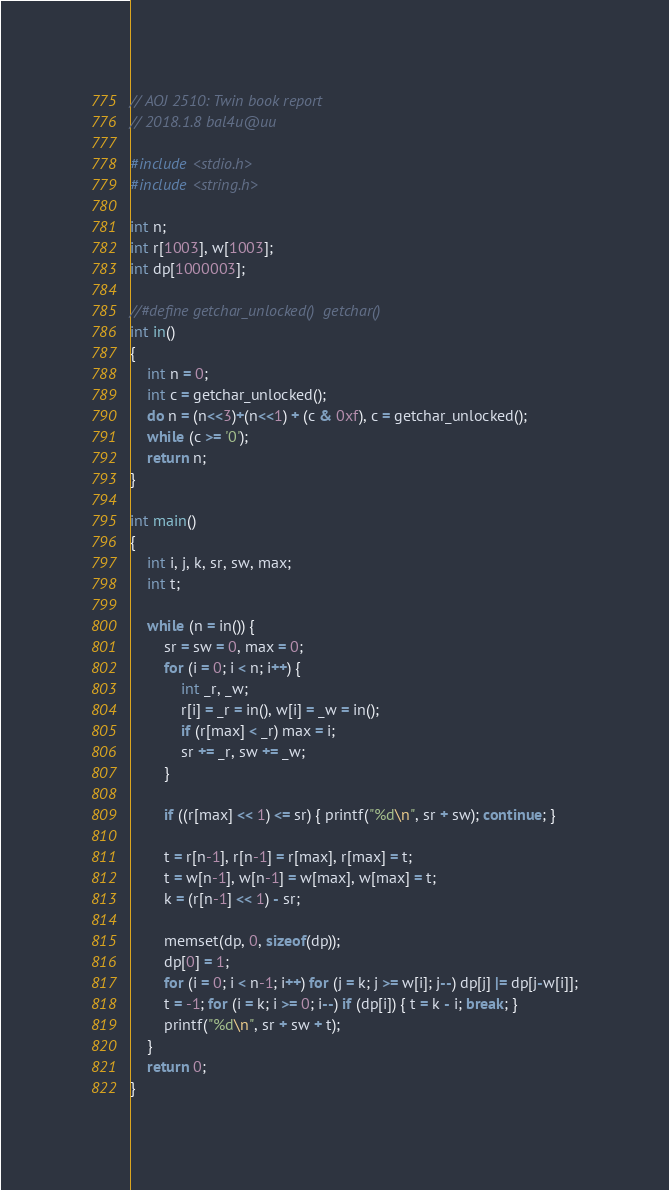<code> <loc_0><loc_0><loc_500><loc_500><_C_>// AOJ 2510: Twin book report
// 2018.1.8 bal4u@uu

#include <stdio.h>
#include <string.h>

int n;
int r[1003], w[1003];
int dp[1000003];

//#define getchar_unlocked()  getchar()
int in()
{
	int n = 0;
	int c = getchar_unlocked();
	do n = (n<<3)+(n<<1) + (c & 0xf), c = getchar_unlocked();
	while (c >= '0');
	return n;
}

int main()
{
	int i, j, k, sr, sw, max;
	int t;

	while (n = in()) {
		sr = sw = 0, max = 0;
		for (i = 0; i < n; i++) {
			int _r, _w;
			r[i] = _r = in(), w[i] = _w = in();
			if (r[max] < _r) max = i;
			sr += _r, sw += _w;
		}

		if ((r[max] << 1) <= sr) { printf("%d\n", sr + sw); continue; }

		t = r[n-1], r[n-1] = r[max], r[max] = t;
		t = w[n-1], w[n-1] = w[max], w[max] = t;
		k = (r[n-1] << 1) - sr;

		memset(dp, 0, sizeof(dp));
		dp[0] = 1;
		for (i = 0; i < n-1; i++) for (j = k; j >= w[i]; j--) dp[j] |= dp[j-w[i]];
		t = -1; for (i = k; i >= 0; i--) if (dp[i]) { t = k - i; break; }
		printf("%d\n", sr + sw + t); 
	}
	return 0;
}
</code> 